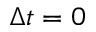<formula> <loc_0><loc_0><loc_500><loc_500>\Delta t = 0</formula> 